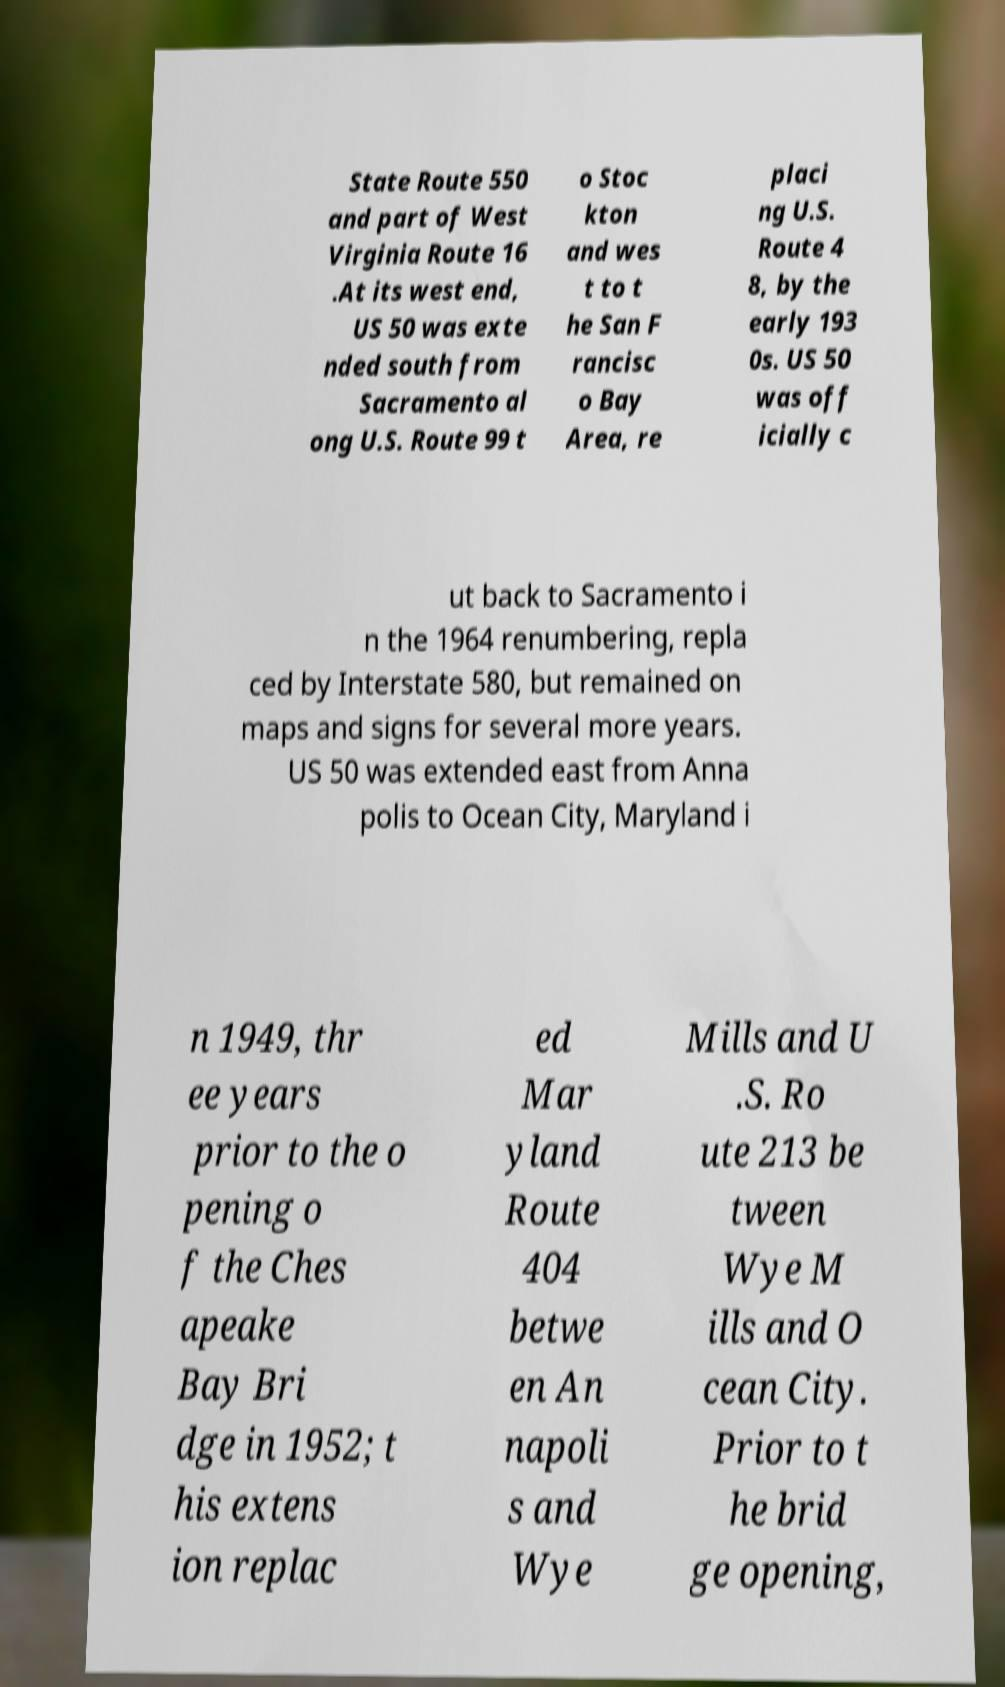What messages or text are displayed in this image? I need them in a readable, typed format. State Route 550 and part of West Virginia Route 16 .At its west end, US 50 was exte nded south from Sacramento al ong U.S. Route 99 t o Stoc kton and wes t to t he San F rancisc o Bay Area, re placi ng U.S. Route 4 8, by the early 193 0s. US 50 was off icially c ut back to Sacramento i n the 1964 renumbering, repla ced by Interstate 580, but remained on maps and signs for several more years. US 50 was extended east from Anna polis to Ocean City, Maryland i n 1949, thr ee years prior to the o pening o f the Ches apeake Bay Bri dge in 1952; t his extens ion replac ed Mar yland Route 404 betwe en An napoli s and Wye Mills and U .S. Ro ute 213 be tween Wye M ills and O cean City. Prior to t he brid ge opening, 